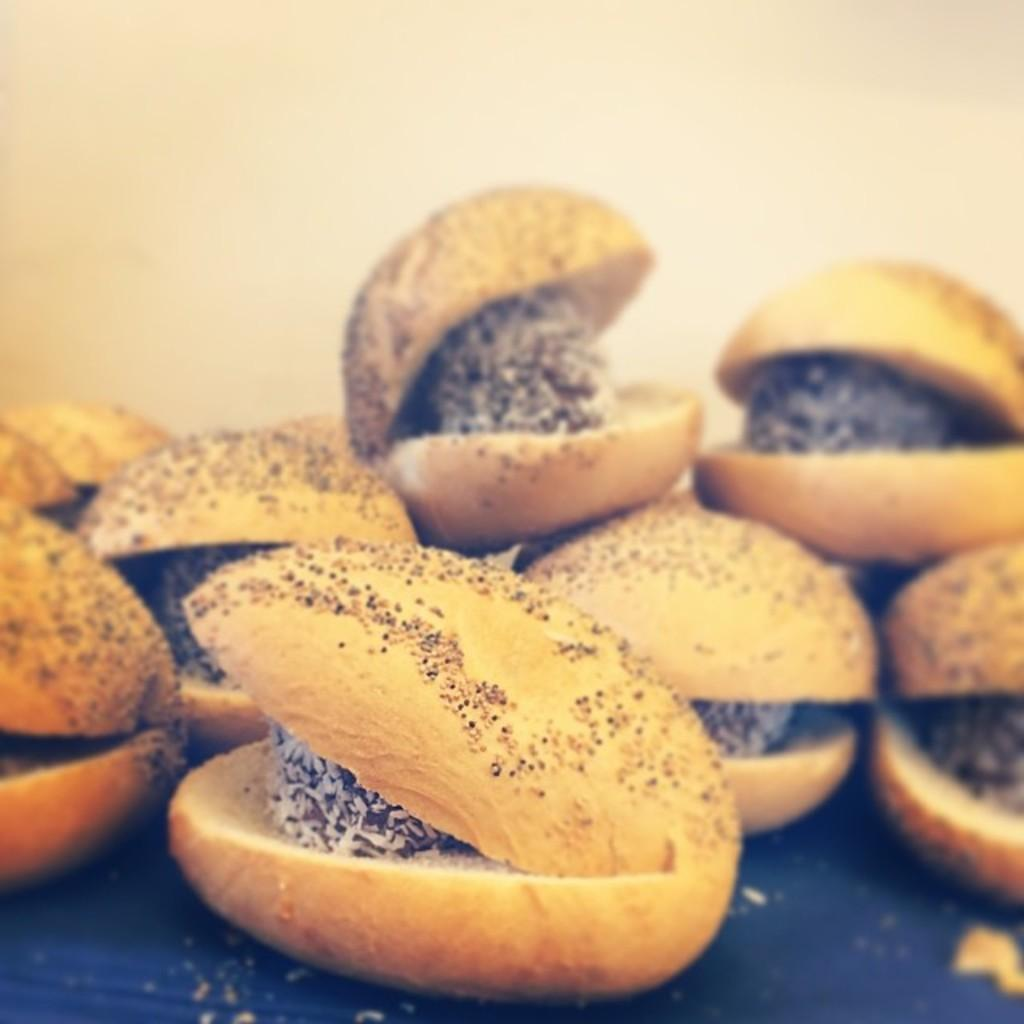What is the main subject of the image? The main subject of the image is food. On what surface is the food placed? The food is on a blue surface. What color is the background of the image? The background of the image is cream in color. How many family members can be seen in the image? There are no family members present in the image; it only features food on a blue surface with a cream-colored background. 